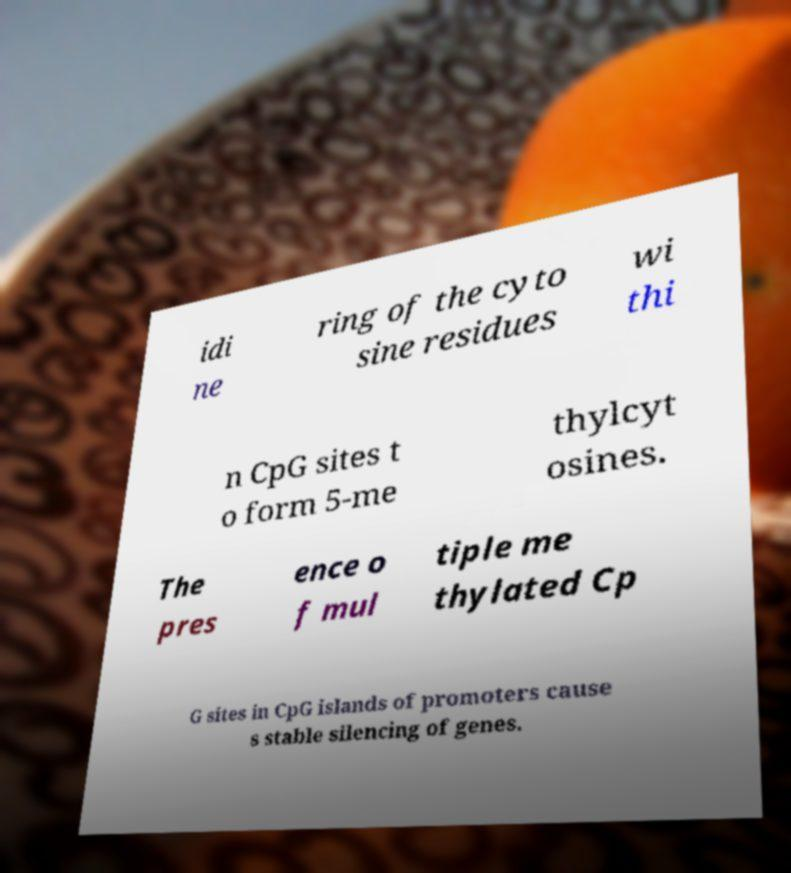I need the written content from this picture converted into text. Can you do that? idi ne ring of the cyto sine residues wi thi n CpG sites t o form 5-me thylcyt osines. The pres ence o f mul tiple me thylated Cp G sites in CpG islands of promoters cause s stable silencing of genes. 